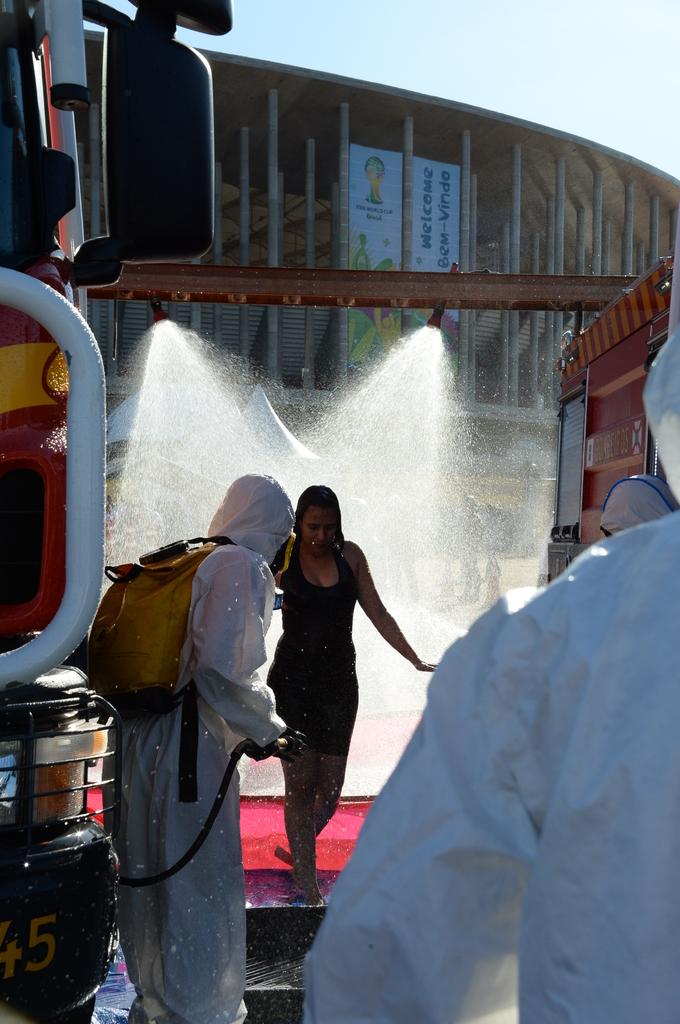How many people are in the image? There is a group of people in the image, but the exact number cannot be determined from the provided facts. What is the primary setting of the image? The image features water, a building, and vehicles, suggesting that it is set near a body of water with a nearby structure and transportation options. Can you describe the vehicles in the image? The provided facts do not specify the type or number of vehicles in the image. What type of wax can be seen melting in the image? There is no wax present in the image. How many stars are visible in the image? The provided facts do not mention any stars in the image. 